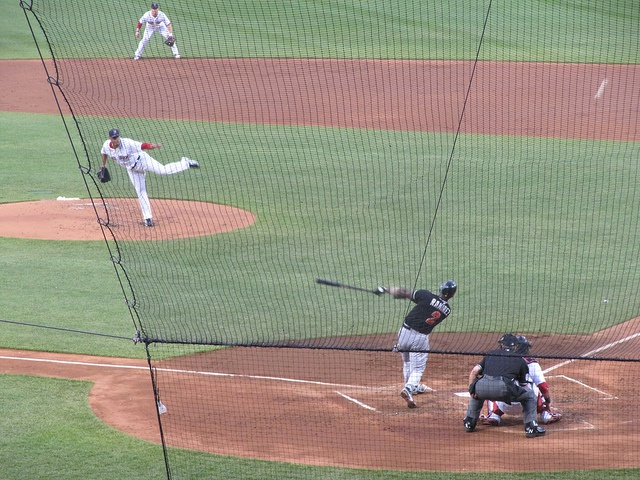Describe the objects in this image and their specific colors. I can see people in gray and black tones, people in gray, darkgray, and black tones, people in gray, lavender, and darkgray tones, people in gray, lavender, black, and darkgray tones, and people in gray, lavender, and darkgray tones in this image. 